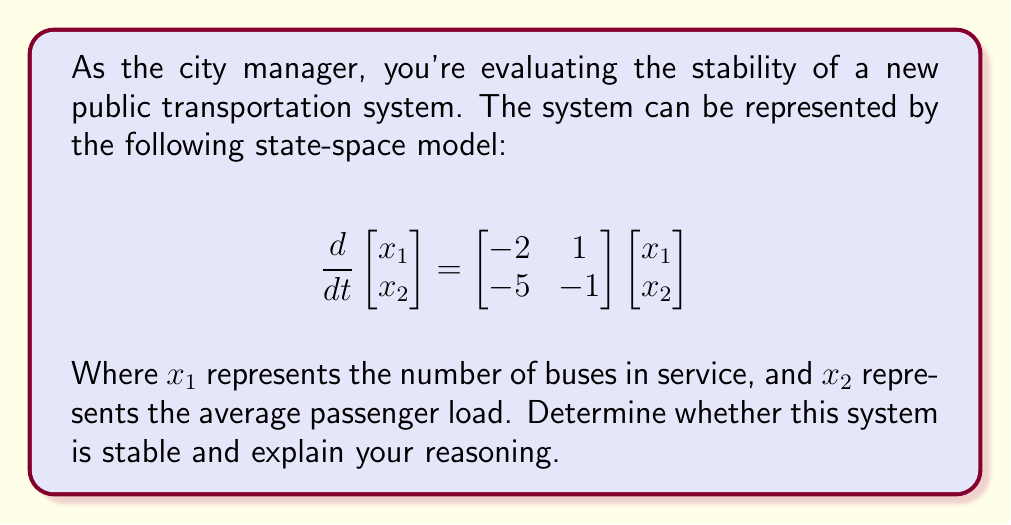Can you answer this question? To analyze the stability of this system, we need to examine the eigenvalues of the state matrix A:

$$A = \begin{bmatrix} -2 & 1 \\ -5 & -1 \end{bmatrix}$$

The system is stable if all eigenvalues have negative real parts. To find the eigenvalues, we solve the characteristic equation:

$$det(A - \lambda I) = 0$$

$$\begin{vmatrix} -2-\lambda & 1 \\ -5 & -1-\lambda \end{vmatrix} = 0$$

$$(-2-\lambda)(-1-\lambda) - (-5)(1) = 0$$

$$\lambda^2 + 3\lambda + 3 = 0$$

Using the quadratic formula, we can solve for $\lambda$:

$$\lambda = \frac{-3 \pm \sqrt{9 - 12}}{2} = \frac{-3 \pm \sqrt{-3}}{2}$$

This gives us two complex conjugate eigenvalues:

$$\lambda_1 = -\frac{3}{2} + i\frac{\sqrt{3}}{2}$$
$$\lambda_2 = -\frac{3}{2} - i\frac{\sqrt{3}}{2}$$

Both eigenvalues have a negative real part $(-\frac{3}{2})$, which indicates that the system is stable. This means that any perturbations in the number of buses in service or average passenger load will eventually return to equilibrium.
Answer: The system is stable because both eigenvalues have negative real parts: $\lambda_1 = -\frac{3}{2} + i\frac{\sqrt{3}}{2}$ and $\lambda_2 = -\frac{3}{2} - i\frac{\sqrt{3}}{2}$. 